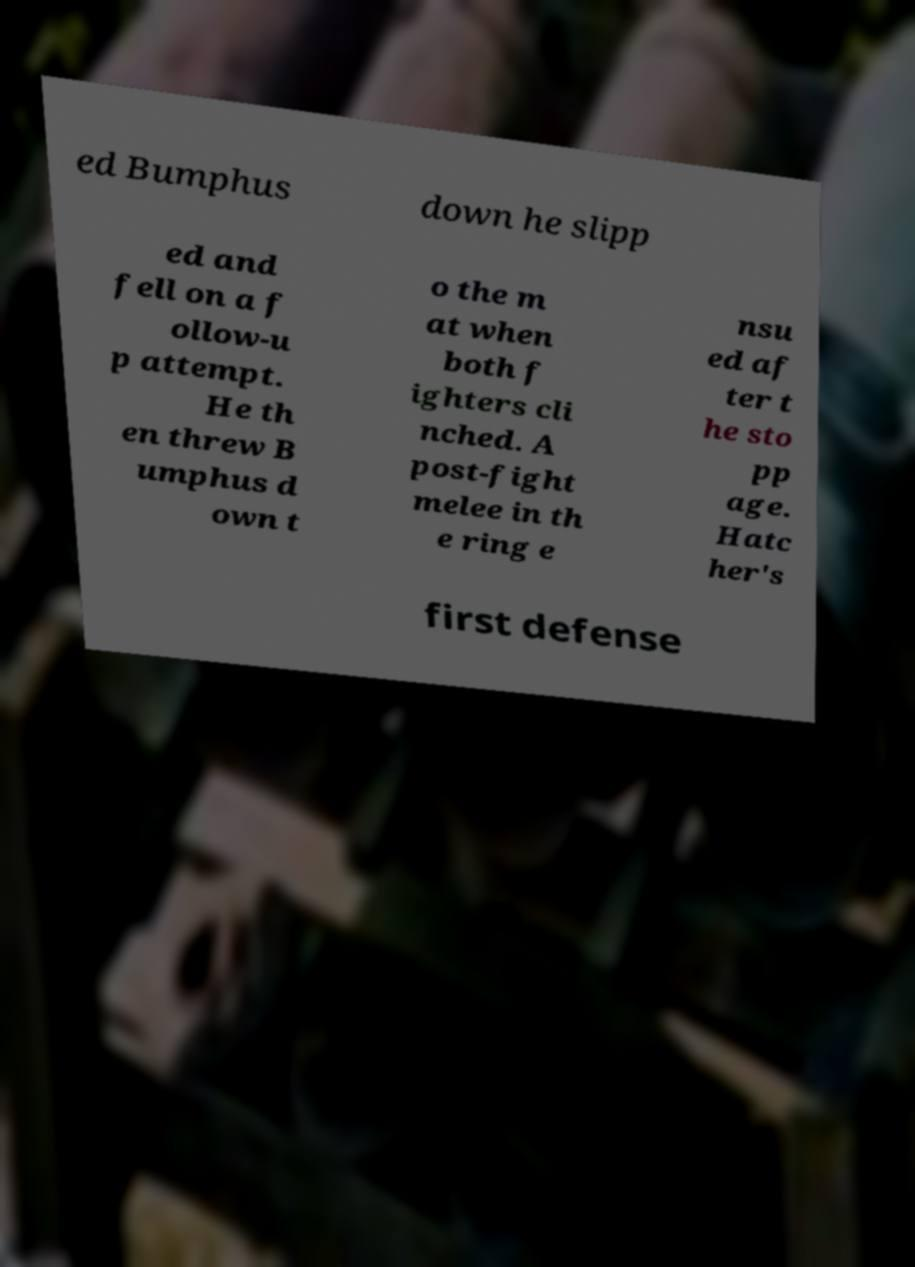Can you read and provide the text displayed in the image?This photo seems to have some interesting text. Can you extract and type it out for me? ed Bumphus down he slipp ed and fell on a f ollow-u p attempt. He th en threw B umphus d own t o the m at when both f ighters cli nched. A post-fight melee in th e ring e nsu ed af ter t he sto pp age. Hatc her's first defense 